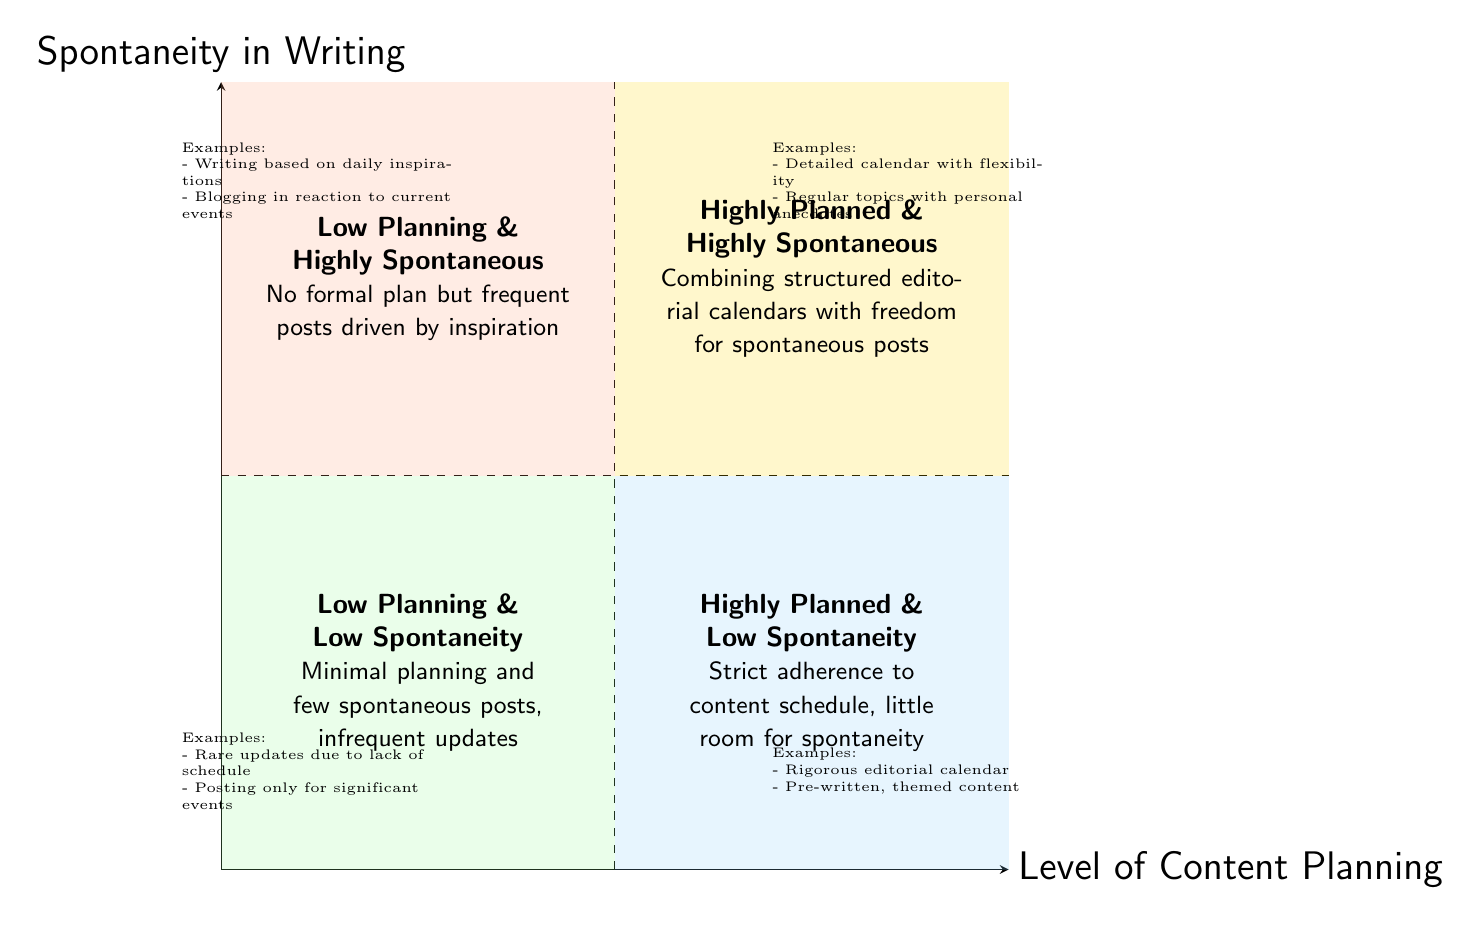What are the four quadrants in the diagram? The diagram consists of four quadrants: Highly Planned & Highly Spontaneous, Low Planning & Low Spontaneity, Highly Planned & Low Spontaneity, and Low Planning & Highly Spontaneous. This is identified by locating each quadrant's label in the sections defined by the axes.
Answer: Highly Planned & Highly Spontaneous, Low Planning & Low Spontaneity, Highly Planned & Low Spontaneity, Low Planning & Highly Spontaneous Which quadrant details a lack of both planning and spontaneity? In the diagram, the quadrant labeled "Low Planning & Low Spontaneity" is specifically described as having minimal planning and few spontaneous posts. This is confirmed by locating the quadrant in the bottom left section.
Answer: Low Planning & Low Spontaneity What examples are provided in the "Highly Planned & Highly Spontaneous" quadrant? The examples located in the "Highly Planned & Highly Spontaneous" quadrant include "Using a detailed editorial calendar for posting dates but allowing flexibility for last-minute inspiration" and "Scheduling regular topics but sprinkling in personal anecdotes or recent experiences." I found these examples listed directly under the corresponding quadrant label.
Answer: Using a detailed editorial calendar for posting dates but allowing flexibility for last-minute inspiration; Scheduling regular topics but sprinkling in personal anecdotes or recent experiences How many quadrants emphasize spontaneity? The diagram shows two quadrants that emphasize spontaneity: "Highly Planned & Highly Spontaneous" and "Low Planning & Highly Spontaneous." These quadrants can be observed in the top right and bottom left sections, respectively.
Answer: Two Which quadrant focuses exclusively on scheduling and does not allow for spontaneous posts? The quadrant titled "Highly Planned & Low Spontaneity" clearly focuses on strict adherence to a content schedule with no room for spontaneous writing. This is identified by its position and description, which explicitly mentions little room for spontaneity.
Answer: Highly Planned & Low Spontaneity What color represents the "Low Planning & Highly Spontaneous" quadrant? The color used for the "Low Planning & Highly Spontaneous" quadrant is a soft orange color defined by the code for filling that quadrant in the diagram, recognized by its position in the chart.
Answer: Light orange 